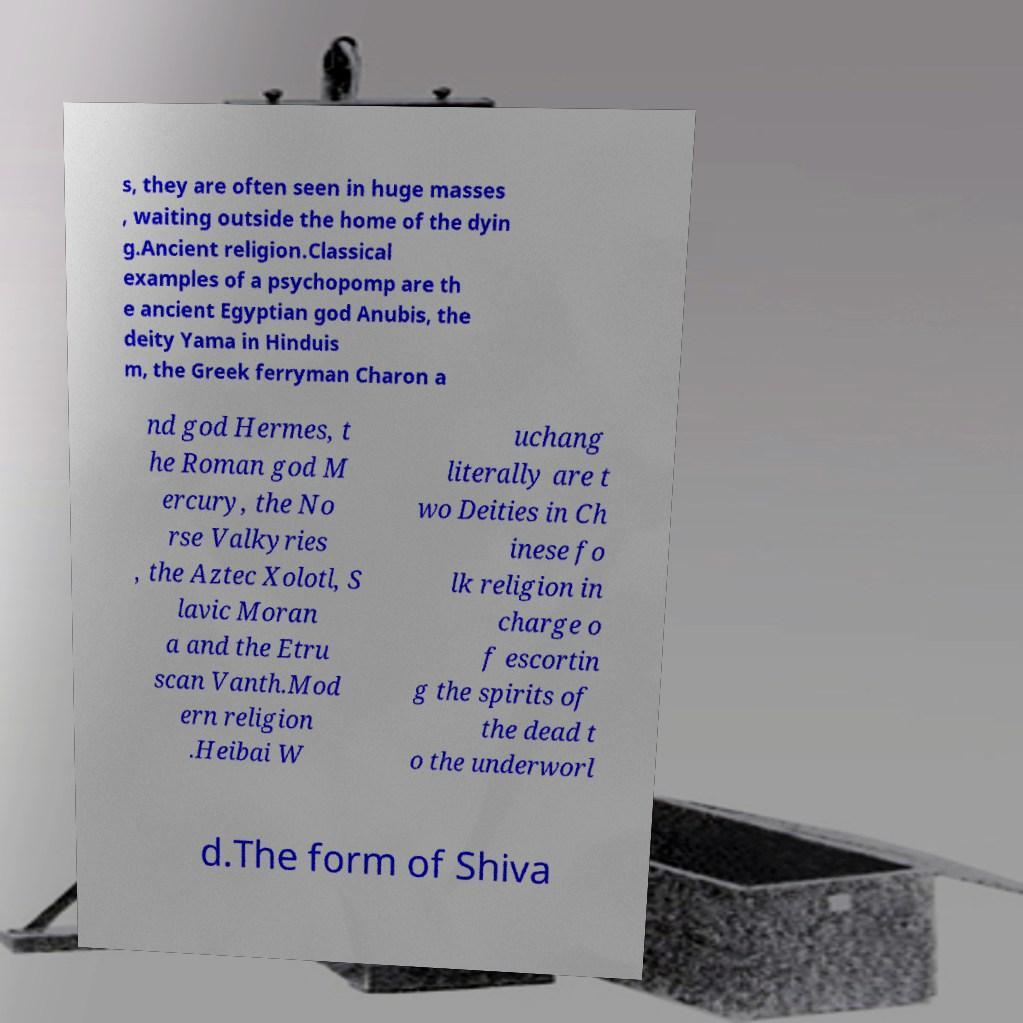Can you accurately transcribe the text from the provided image for me? s, they are often seen in huge masses , waiting outside the home of the dyin g.Ancient religion.Classical examples of a psychopomp are th e ancient Egyptian god Anubis, the deity Yama in Hinduis m, the Greek ferryman Charon a nd god Hermes, t he Roman god M ercury, the No rse Valkyries , the Aztec Xolotl, S lavic Moran a and the Etru scan Vanth.Mod ern religion .Heibai W uchang literally are t wo Deities in Ch inese fo lk religion in charge o f escortin g the spirits of the dead t o the underworl d.The form of Shiva 